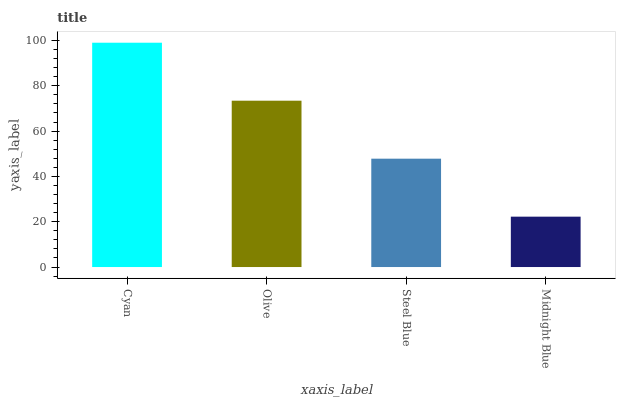Is Olive the minimum?
Answer yes or no. No. Is Olive the maximum?
Answer yes or no. No. Is Cyan greater than Olive?
Answer yes or no. Yes. Is Olive less than Cyan?
Answer yes or no. Yes. Is Olive greater than Cyan?
Answer yes or no. No. Is Cyan less than Olive?
Answer yes or no. No. Is Olive the high median?
Answer yes or no. Yes. Is Steel Blue the low median?
Answer yes or no. Yes. Is Steel Blue the high median?
Answer yes or no. No. Is Olive the low median?
Answer yes or no. No. 